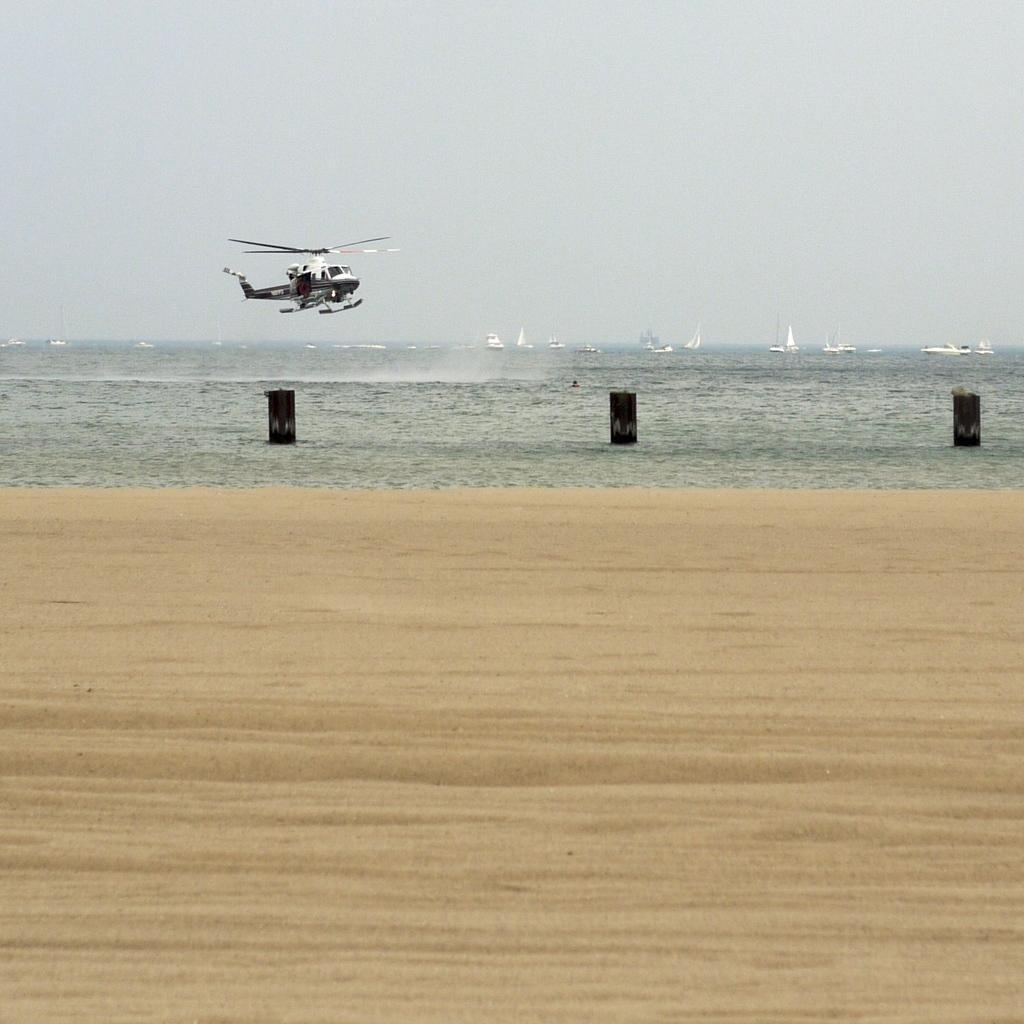Describe this image in one or two sentences. In the image we can see a helicopter, sand, water and a sky. There are many boats in the water, these are the objects. 